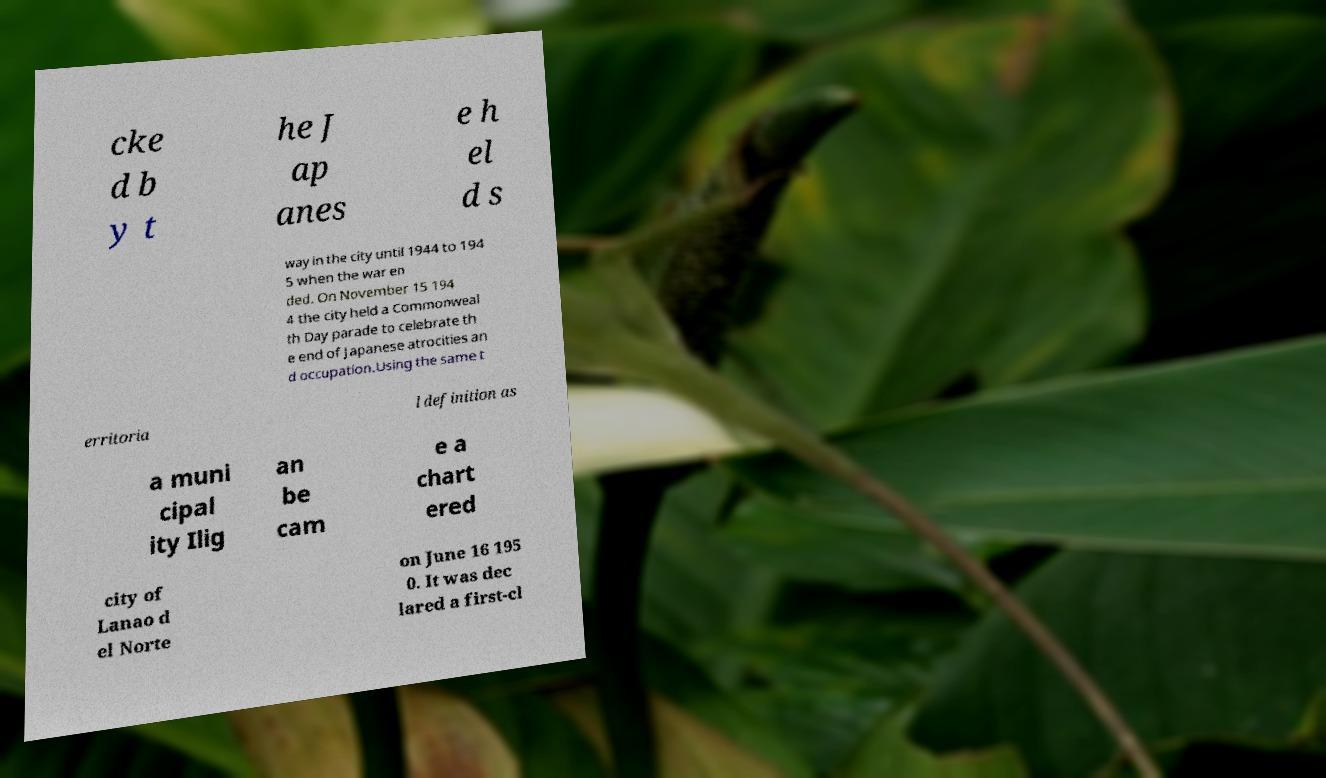For documentation purposes, I need the text within this image transcribed. Could you provide that? cke d b y t he J ap anes e h el d s way in the city until 1944 to 194 5 when the war en ded. On November 15 194 4 the city held a Commonweal th Day parade to celebrate th e end of Japanese atrocities an d occupation.Using the same t erritoria l definition as a muni cipal ity Ilig an be cam e a chart ered city of Lanao d el Norte on June 16 195 0. It was dec lared a first-cl 